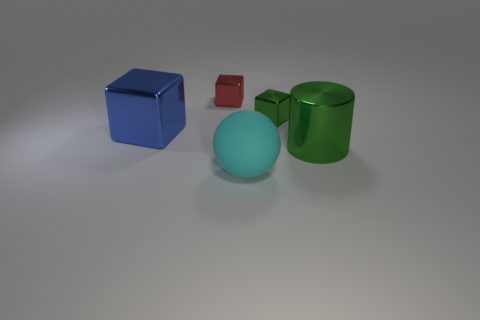Subtract all green metallic blocks. How many blocks are left? 2 Add 2 green metallic cylinders. How many objects exist? 7 Subtract all cubes. How many objects are left? 2 Subtract all gray cubes. Subtract all yellow spheres. How many cubes are left? 3 Add 4 blue matte blocks. How many blue matte blocks exist? 4 Subtract 1 cyan balls. How many objects are left? 4 Subtract all small green cubes. Subtract all blue blocks. How many objects are left? 3 Add 4 tiny red objects. How many tiny red objects are left? 5 